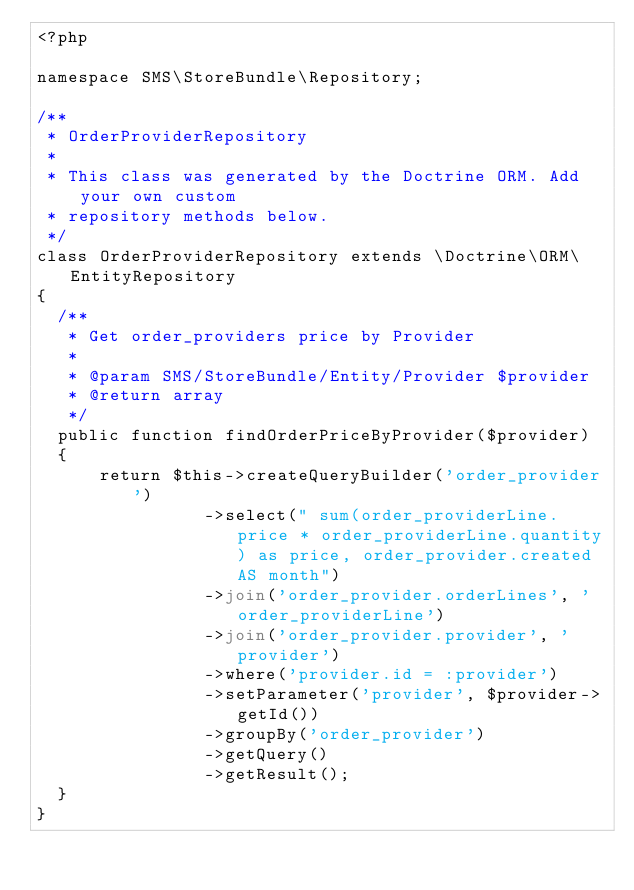Convert code to text. <code><loc_0><loc_0><loc_500><loc_500><_PHP_><?php

namespace SMS\StoreBundle\Repository;

/**
 * OrderProviderRepository
 *
 * This class was generated by the Doctrine ORM. Add your own custom
 * repository methods below.
 */
class OrderProviderRepository extends \Doctrine\ORM\EntityRepository
{
  /**
   * Get order_providers price by Provider
   *
   * @param SMS/StoreBundle/Entity/Provider $provider
   * @return array
   */
  public function findOrderPriceByProvider($provider)
  {
      return $this->createQueryBuilder('order_provider')
                ->select(" sum(order_providerLine.price * order_providerLine.quantity) as price, order_provider.created AS month")
                ->join('order_provider.orderLines', 'order_providerLine')
                ->join('order_provider.provider', 'provider')
                ->where('provider.id = :provider')
                ->setParameter('provider', $provider->getId())
                ->groupBy('order_provider')
                ->getQuery()
                ->getResult();
  }
}
</code> 